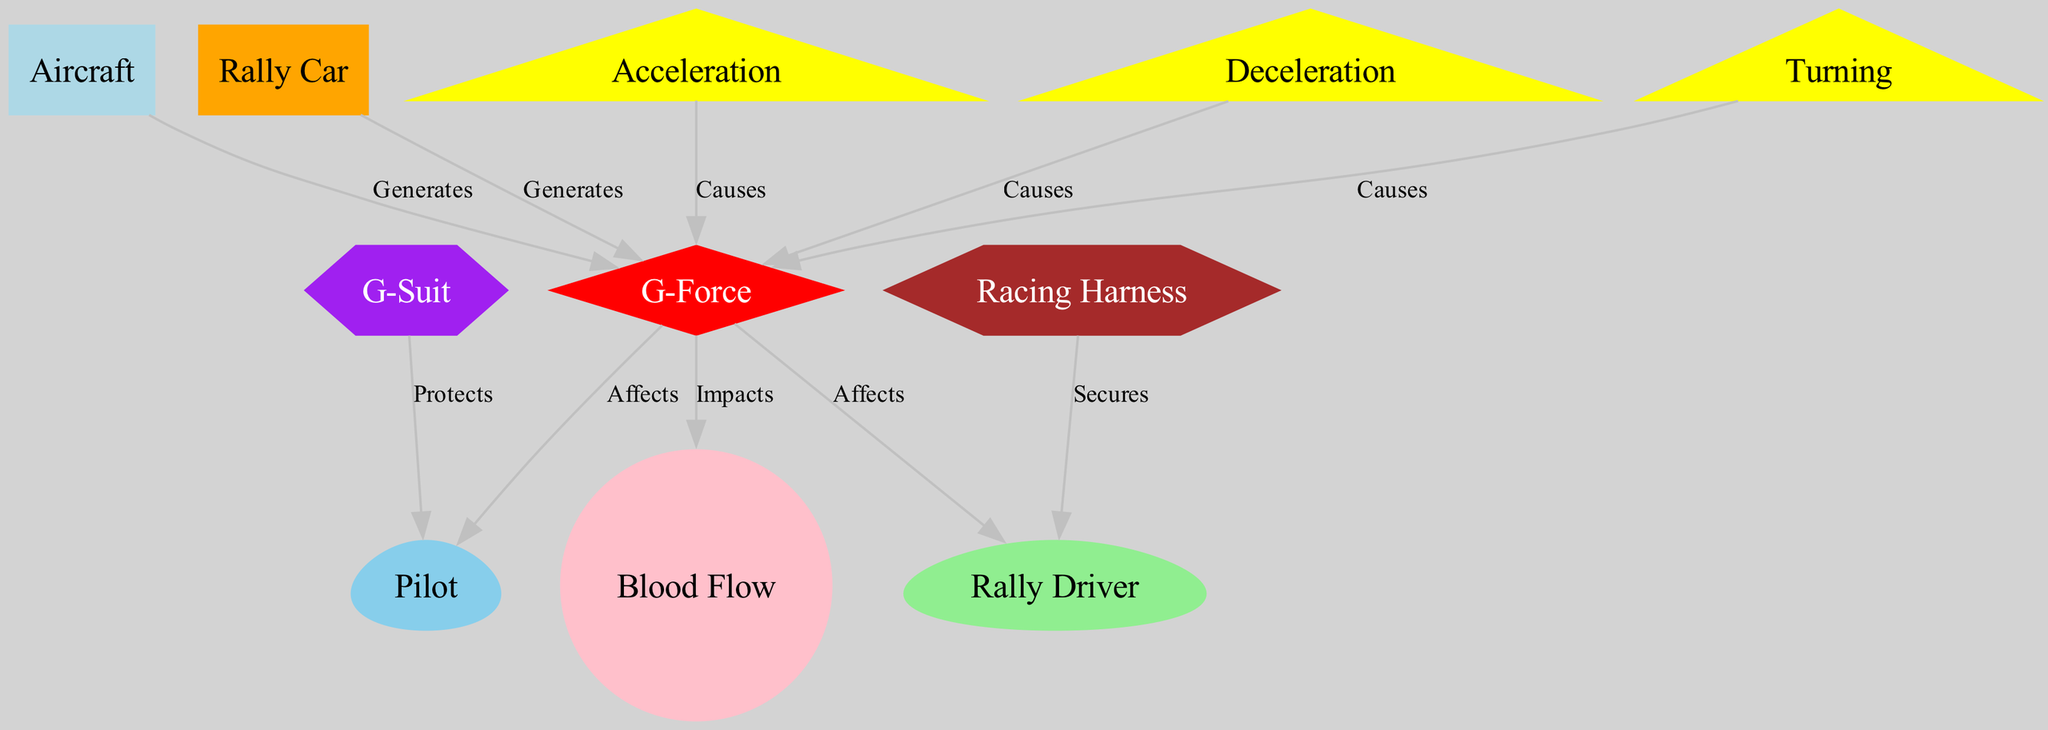What is the color of the G-Force node? The G-Force node is represented as a diamond shape and filled with the color red according to the node styles defined in the diagram.
Answer: red How many nodes are in the diagram? Counting all the unique entries in the nodes list, there are a total of 10 distinct nodes represented in the diagram.
Answer: 10 What does G-Force impact? The diagram indicates that G-Force impacts blood flow, which is labeled as a direct relationship from G-Force to blood flow.
Answer: Blood Flow Which node generates G-Force in aircraft? The diagram specifies that the aircraft generates G-Force, creating a direct link from the aircraft node to the G-Force node.
Answer: Aircraft What causes G-Force during turning? The diagram shows that turning causes G-Force, indicated by the directed edge from the turning node to the G-Force node, reflecting the physics of maneuvering.
Answer: Turning What protects pilots from G-Force? G-Suit is indicated as the protective gear for pilots against G-Force, clearly represented as the node linked from G-Suit to the pilot node.
Answer: G-Suit What secures rally drivers in their vehicles? The diagram illustrates that a racing harness secures rally drivers, with a directed connection from the harness node to the rally driver node.
Answer: Racing Harness How does deceleration contribute to G-Force? The diagram establishes that deceleration causes G-Force, as evidenced by the directed edge from the deceleration node to the G-Force node, linking the cause to the effect.
Answer: Causes What role does acceleration play in G-Force? Similar to deceleration, the diagram shows that acceleration also causes G-Force, with a direct edge from the acceleration node to G-Force, linking the action to the result.
Answer: Causes 